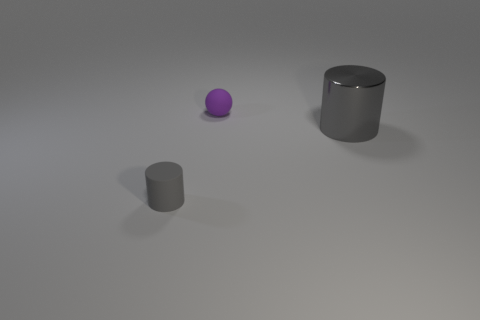How many large things are there?
Provide a short and direct response. 1. What number of gray rubber objects are the same size as the shiny cylinder?
Offer a terse response. 0. What is the tiny gray cylinder made of?
Keep it short and to the point. Rubber. There is a small sphere; is its color the same as the object to the left of the matte ball?
Make the answer very short. No. Are there any other things that are the same size as the gray rubber cylinder?
Provide a short and direct response. Yes. What is the size of the thing that is both to the right of the tiny gray object and left of the gray metallic cylinder?
Keep it short and to the point. Small. There is a gray object that is made of the same material as the ball; what shape is it?
Offer a very short reply. Cylinder. Do the ball and the thing on the right side of the tiny ball have the same material?
Offer a terse response. No. There is a small matte object left of the matte ball; is there a big object on the left side of it?
Provide a succinct answer. No. There is a large gray object that is the same shape as the small gray thing; what material is it?
Your response must be concise. Metal. 